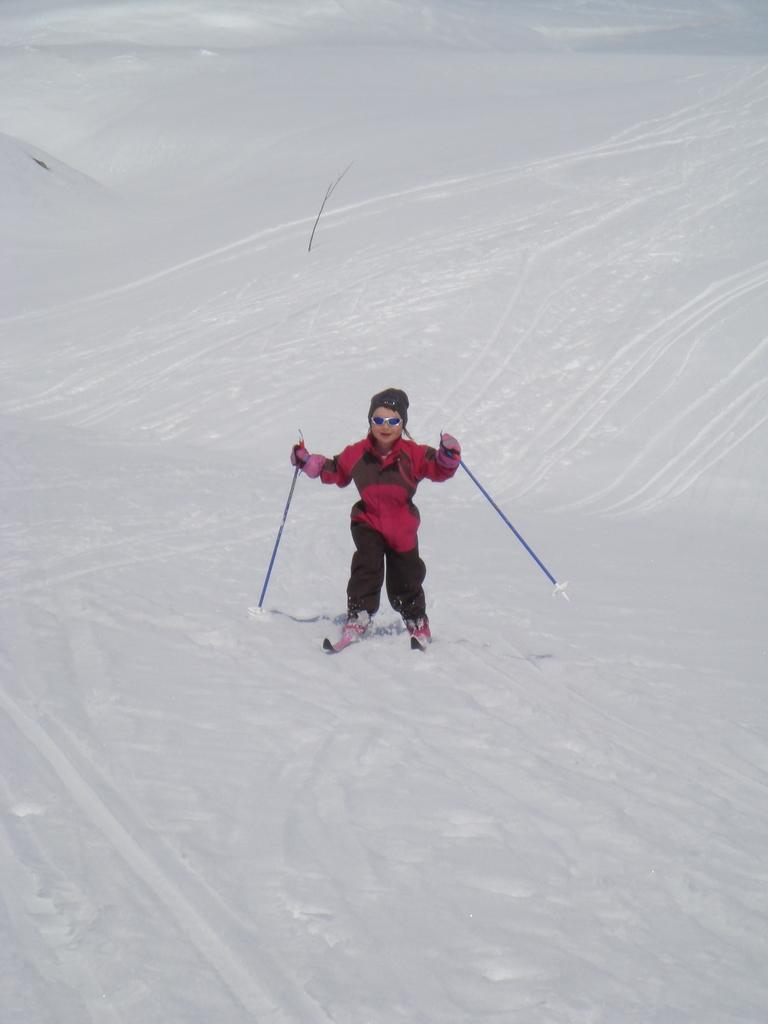What is the person in the image wearing? The person is wearing a red and grey color dress in the image. What is the person holding in the image? The person is holding sticks in the image. Can you describe the appearance of another person in the image? There is a person wearing goggles in the image. What type of terrain is visible in the image? The person is on the snow in the image. What type of cloud can be seen in the image? There is no cloud visible in the image; the person is on the snow. How many dolls are present in the image? There are no dolls present in the image. 